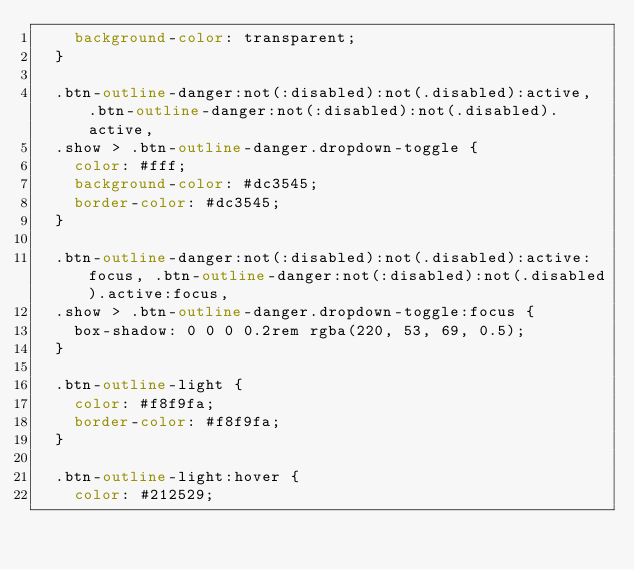Convert code to text. <code><loc_0><loc_0><loc_500><loc_500><_CSS_>    background-color: transparent;
  }
  
  .btn-outline-danger:not(:disabled):not(.disabled):active, .btn-outline-danger:not(:disabled):not(.disabled).active,
  .show > .btn-outline-danger.dropdown-toggle {
    color: #fff;
    background-color: #dc3545;
    border-color: #dc3545;
  }
  
  .btn-outline-danger:not(:disabled):not(.disabled):active:focus, .btn-outline-danger:not(:disabled):not(.disabled).active:focus,
  .show > .btn-outline-danger.dropdown-toggle:focus {
    box-shadow: 0 0 0 0.2rem rgba(220, 53, 69, 0.5);
  }
  
  .btn-outline-light {
    color: #f8f9fa;
    border-color: #f8f9fa;
  }
  
  .btn-outline-light:hover {
    color: #212529;</code> 